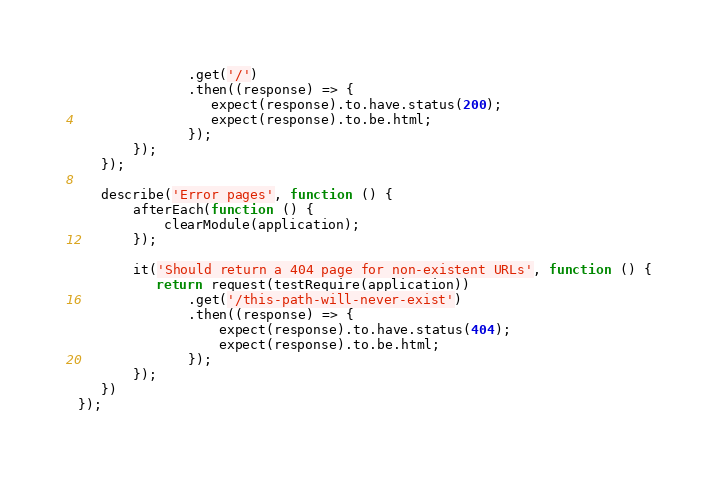Convert code to text. <code><loc_0><loc_0><loc_500><loc_500><_JavaScript_>              .get('/')
              .then((response) => {
                 expect(response).to.have.status(200);
                 expect(response).to.be.html;
              });
       });
   });

   describe('Error pages', function () {
       afterEach(function () {
           clearModule(application);
       });

       it('Should return a 404 page for non-existent URLs', function () {
          return request(testRequire(application))
              .get('/this-path-will-never-exist')
              .then((response) => {
                  expect(response).to.have.status(404);
                  expect(response).to.be.html;
              });
       });
   })
});
</code> 